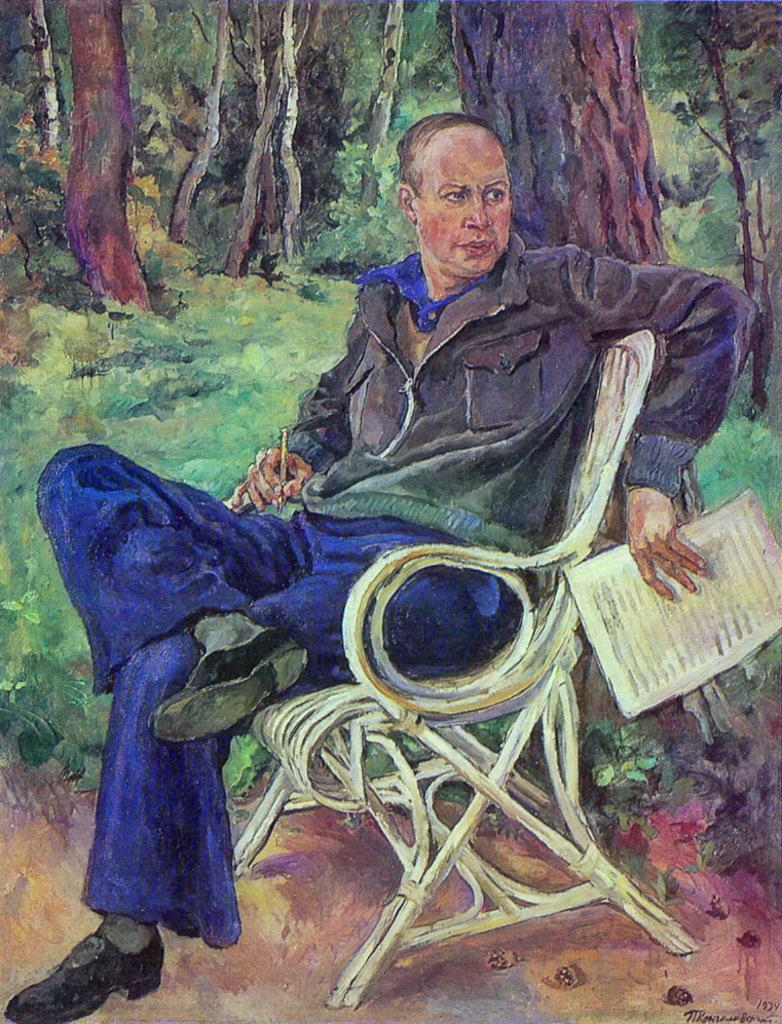What is the main subject of the image? The image contains a painting. What is the person in the painting doing? The person in the painting is sitting on a bench. What objects is the person holding in the painting? The person in the painting is holding a paper and a pen. What can be seen behind the person in the painting? There are plants and trees behind the person in the painting. What type of profit can be seen on the shelf in the image? There is no shelf or profit present in the image; it features a painting of a person sitting on a bench. What type of iron is visible behind the person in the painting? There is no iron visible behind the person in the painting; only plants and trees are present. 